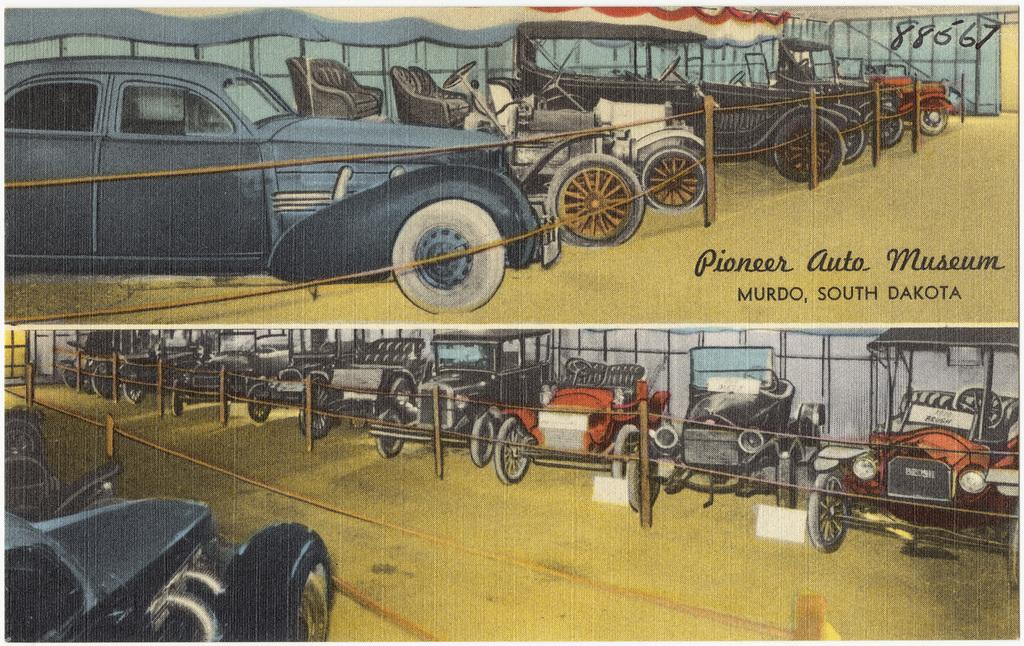What can be seen hanging on the wall in the image? There is a poster in the image. What type of objects are present in the image that move? There are vehicles in the image. What structures are present in the image that support something? There are poles in the image. What type of barrier can be seen in the image? There is a fence in the image. What type of written information is present in the image? There is some text in the image. What type of architectural feature can be seen in the background of the image? There is a wall visible in the background of the image. How many toes are visible on the poster in the image? There are no toes visible on the poster in the image. What type of camp can be seen in the background of the image? There is no camp present in the image. 